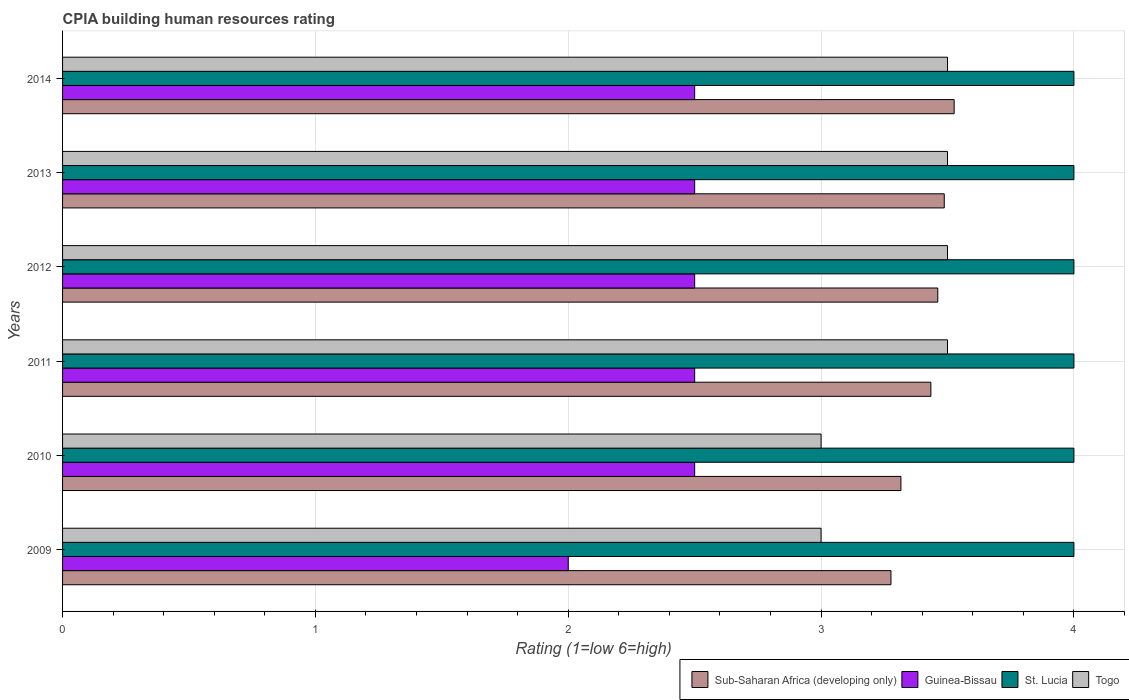Are the number of bars on each tick of the Y-axis equal?
Offer a very short reply. Yes. What is the label of the 5th group of bars from the top?
Keep it short and to the point. 2010. In how many cases, is the number of bars for a given year not equal to the number of legend labels?
Provide a succinct answer. 0. What is the CPIA rating in St. Lucia in 2010?
Your response must be concise. 4. Across all years, what is the maximum CPIA rating in St. Lucia?
Offer a very short reply. 4. Across all years, what is the minimum CPIA rating in Guinea-Bissau?
Keep it short and to the point. 2. In which year was the CPIA rating in Sub-Saharan Africa (developing only) maximum?
Your answer should be compact. 2014. What is the difference between the CPIA rating in Sub-Saharan Africa (developing only) in 2010 and that in 2013?
Offer a terse response. -0.17. What is the difference between the CPIA rating in Guinea-Bissau in 2011 and the CPIA rating in Togo in 2013?
Ensure brevity in your answer.  -1. What is the average CPIA rating in St. Lucia per year?
Offer a very short reply. 4. In how many years, is the CPIA rating in Togo greater than 0.2 ?
Give a very brief answer. 6. What is the ratio of the CPIA rating in Togo in 2010 to that in 2011?
Your response must be concise. 0.86. Is the CPIA rating in Sub-Saharan Africa (developing only) in 2009 less than that in 2013?
Provide a short and direct response. Yes. What is the difference between the highest and the second highest CPIA rating in Togo?
Make the answer very short. 0. Is it the case that in every year, the sum of the CPIA rating in St. Lucia and CPIA rating in Togo is greater than the sum of CPIA rating in Sub-Saharan Africa (developing only) and CPIA rating in Guinea-Bissau?
Offer a very short reply. No. What does the 1st bar from the top in 2009 represents?
Provide a succinct answer. Togo. What does the 3rd bar from the bottom in 2009 represents?
Make the answer very short. St. Lucia. Are all the bars in the graph horizontal?
Keep it short and to the point. Yes. What is the difference between two consecutive major ticks on the X-axis?
Your answer should be very brief. 1. Are the values on the major ticks of X-axis written in scientific E-notation?
Give a very brief answer. No. Where does the legend appear in the graph?
Provide a short and direct response. Bottom right. How many legend labels are there?
Give a very brief answer. 4. How are the legend labels stacked?
Keep it short and to the point. Horizontal. What is the title of the graph?
Offer a very short reply. CPIA building human resources rating. What is the label or title of the X-axis?
Make the answer very short. Rating (1=low 6=high). What is the Rating (1=low 6=high) of Sub-Saharan Africa (developing only) in 2009?
Your response must be concise. 3.28. What is the Rating (1=low 6=high) in Guinea-Bissau in 2009?
Provide a succinct answer. 2. What is the Rating (1=low 6=high) in St. Lucia in 2009?
Keep it short and to the point. 4. What is the Rating (1=low 6=high) of Togo in 2009?
Offer a terse response. 3. What is the Rating (1=low 6=high) in Sub-Saharan Africa (developing only) in 2010?
Make the answer very short. 3.32. What is the Rating (1=low 6=high) in Sub-Saharan Africa (developing only) in 2011?
Your answer should be very brief. 3.43. What is the Rating (1=low 6=high) in St. Lucia in 2011?
Your response must be concise. 4. What is the Rating (1=low 6=high) of Sub-Saharan Africa (developing only) in 2012?
Provide a short and direct response. 3.46. What is the Rating (1=low 6=high) of St. Lucia in 2012?
Ensure brevity in your answer.  4. What is the Rating (1=low 6=high) in Togo in 2012?
Offer a terse response. 3.5. What is the Rating (1=low 6=high) of Sub-Saharan Africa (developing only) in 2013?
Ensure brevity in your answer.  3.49. What is the Rating (1=low 6=high) in Sub-Saharan Africa (developing only) in 2014?
Your answer should be compact. 3.53. What is the Rating (1=low 6=high) of Guinea-Bissau in 2014?
Offer a very short reply. 2.5. What is the Rating (1=low 6=high) in St. Lucia in 2014?
Provide a short and direct response. 4. What is the Rating (1=low 6=high) in Togo in 2014?
Your response must be concise. 3.5. Across all years, what is the maximum Rating (1=low 6=high) of Sub-Saharan Africa (developing only)?
Your answer should be very brief. 3.53. Across all years, what is the maximum Rating (1=low 6=high) of Guinea-Bissau?
Offer a terse response. 2.5. Across all years, what is the maximum Rating (1=low 6=high) of St. Lucia?
Ensure brevity in your answer.  4. Across all years, what is the maximum Rating (1=low 6=high) of Togo?
Give a very brief answer. 3.5. Across all years, what is the minimum Rating (1=low 6=high) of Sub-Saharan Africa (developing only)?
Keep it short and to the point. 3.28. Across all years, what is the minimum Rating (1=low 6=high) in Guinea-Bissau?
Your response must be concise. 2. Across all years, what is the minimum Rating (1=low 6=high) of St. Lucia?
Your answer should be very brief. 4. Across all years, what is the minimum Rating (1=low 6=high) in Togo?
Give a very brief answer. 3. What is the total Rating (1=low 6=high) in Sub-Saharan Africa (developing only) in the graph?
Your response must be concise. 20.5. What is the total Rating (1=low 6=high) of Guinea-Bissau in the graph?
Ensure brevity in your answer.  14.5. What is the difference between the Rating (1=low 6=high) in Sub-Saharan Africa (developing only) in 2009 and that in 2010?
Provide a succinct answer. -0.04. What is the difference between the Rating (1=low 6=high) of Guinea-Bissau in 2009 and that in 2010?
Offer a terse response. -0.5. What is the difference between the Rating (1=low 6=high) in Sub-Saharan Africa (developing only) in 2009 and that in 2011?
Your response must be concise. -0.16. What is the difference between the Rating (1=low 6=high) in Guinea-Bissau in 2009 and that in 2011?
Your response must be concise. -0.5. What is the difference between the Rating (1=low 6=high) of St. Lucia in 2009 and that in 2011?
Provide a succinct answer. 0. What is the difference between the Rating (1=low 6=high) in Sub-Saharan Africa (developing only) in 2009 and that in 2012?
Provide a short and direct response. -0.19. What is the difference between the Rating (1=low 6=high) in St. Lucia in 2009 and that in 2012?
Offer a very short reply. 0. What is the difference between the Rating (1=low 6=high) of Sub-Saharan Africa (developing only) in 2009 and that in 2013?
Offer a very short reply. -0.21. What is the difference between the Rating (1=low 6=high) of Togo in 2009 and that in 2013?
Your response must be concise. -0.5. What is the difference between the Rating (1=low 6=high) in Guinea-Bissau in 2009 and that in 2014?
Your answer should be very brief. -0.5. What is the difference between the Rating (1=low 6=high) of Sub-Saharan Africa (developing only) in 2010 and that in 2011?
Ensure brevity in your answer.  -0.12. What is the difference between the Rating (1=low 6=high) of Guinea-Bissau in 2010 and that in 2011?
Offer a very short reply. 0. What is the difference between the Rating (1=low 6=high) of Sub-Saharan Africa (developing only) in 2010 and that in 2012?
Keep it short and to the point. -0.15. What is the difference between the Rating (1=low 6=high) of St. Lucia in 2010 and that in 2012?
Ensure brevity in your answer.  0. What is the difference between the Rating (1=low 6=high) in Togo in 2010 and that in 2012?
Make the answer very short. -0.5. What is the difference between the Rating (1=low 6=high) of Sub-Saharan Africa (developing only) in 2010 and that in 2013?
Your answer should be very brief. -0.17. What is the difference between the Rating (1=low 6=high) of Guinea-Bissau in 2010 and that in 2013?
Your answer should be compact. 0. What is the difference between the Rating (1=low 6=high) of Togo in 2010 and that in 2013?
Keep it short and to the point. -0.5. What is the difference between the Rating (1=low 6=high) of Sub-Saharan Africa (developing only) in 2010 and that in 2014?
Ensure brevity in your answer.  -0.21. What is the difference between the Rating (1=low 6=high) of Guinea-Bissau in 2010 and that in 2014?
Ensure brevity in your answer.  0. What is the difference between the Rating (1=low 6=high) in St. Lucia in 2010 and that in 2014?
Ensure brevity in your answer.  0. What is the difference between the Rating (1=low 6=high) in Sub-Saharan Africa (developing only) in 2011 and that in 2012?
Your answer should be very brief. -0.03. What is the difference between the Rating (1=low 6=high) in Togo in 2011 and that in 2012?
Offer a terse response. 0. What is the difference between the Rating (1=low 6=high) of Sub-Saharan Africa (developing only) in 2011 and that in 2013?
Your answer should be compact. -0.05. What is the difference between the Rating (1=low 6=high) of St. Lucia in 2011 and that in 2013?
Make the answer very short. 0. What is the difference between the Rating (1=low 6=high) of Togo in 2011 and that in 2013?
Your answer should be very brief. 0. What is the difference between the Rating (1=low 6=high) of Sub-Saharan Africa (developing only) in 2011 and that in 2014?
Provide a short and direct response. -0.09. What is the difference between the Rating (1=low 6=high) in St. Lucia in 2011 and that in 2014?
Make the answer very short. 0. What is the difference between the Rating (1=low 6=high) of Sub-Saharan Africa (developing only) in 2012 and that in 2013?
Keep it short and to the point. -0.03. What is the difference between the Rating (1=low 6=high) of Guinea-Bissau in 2012 and that in 2013?
Provide a short and direct response. 0. What is the difference between the Rating (1=low 6=high) of St. Lucia in 2012 and that in 2013?
Your answer should be very brief. 0. What is the difference between the Rating (1=low 6=high) in Sub-Saharan Africa (developing only) in 2012 and that in 2014?
Offer a terse response. -0.06. What is the difference between the Rating (1=low 6=high) in Guinea-Bissau in 2012 and that in 2014?
Make the answer very short. 0. What is the difference between the Rating (1=low 6=high) of Togo in 2012 and that in 2014?
Provide a succinct answer. 0. What is the difference between the Rating (1=low 6=high) of Sub-Saharan Africa (developing only) in 2013 and that in 2014?
Give a very brief answer. -0.04. What is the difference between the Rating (1=low 6=high) of Sub-Saharan Africa (developing only) in 2009 and the Rating (1=low 6=high) of Guinea-Bissau in 2010?
Offer a very short reply. 0.78. What is the difference between the Rating (1=low 6=high) of Sub-Saharan Africa (developing only) in 2009 and the Rating (1=low 6=high) of St. Lucia in 2010?
Keep it short and to the point. -0.72. What is the difference between the Rating (1=low 6=high) in Sub-Saharan Africa (developing only) in 2009 and the Rating (1=low 6=high) in Togo in 2010?
Offer a very short reply. 0.28. What is the difference between the Rating (1=low 6=high) of Sub-Saharan Africa (developing only) in 2009 and the Rating (1=low 6=high) of Guinea-Bissau in 2011?
Your answer should be compact. 0.78. What is the difference between the Rating (1=low 6=high) of Sub-Saharan Africa (developing only) in 2009 and the Rating (1=low 6=high) of St. Lucia in 2011?
Your answer should be compact. -0.72. What is the difference between the Rating (1=low 6=high) of Sub-Saharan Africa (developing only) in 2009 and the Rating (1=low 6=high) of Togo in 2011?
Keep it short and to the point. -0.22. What is the difference between the Rating (1=low 6=high) of St. Lucia in 2009 and the Rating (1=low 6=high) of Togo in 2011?
Give a very brief answer. 0.5. What is the difference between the Rating (1=low 6=high) in Sub-Saharan Africa (developing only) in 2009 and the Rating (1=low 6=high) in Guinea-Bissau in 2012?
Offer a very short reply. 0.78. What is the difference between the Rating (1=low 6=high) in Sub-Saharan Africa (developing only) in 2009 and the Rating (1=low 6=high) in St. Lucia in 2012?
Your answer should be compact. -0.72. What is the difference between the Rating (1=low 6=high) of Sub-Saharan Africa (developing only) in 2009 and the Rating (1=low 6=high) of Togo in 2012?
Give a very brief answer. -0.22. What is the difference between the Rating (1=low 6=high) in Guinea-Bissau in 2009 and the Rating (1=low 6=high) in St. Lucia in 2012?
Provide a succinct answer. -2. What is the difference between the Rating (1=low 6=high) of St. Lucia in 2009 and the Rating (1=low 6=high) of Togo in 2012?
Provide a short and direct response. 0.5. What is the difference between the Rating (1=low 6=high) of Sub-Saharan Africa (developing only) in 2009 and the Rating (1=low 6=high) of Guinea-Bissau in 2013?
Your answer should be very brief. 0.78. What is the difference between the Rating (1=low 6=high) in Sub-Saharan Africa (developing only) in 2009 and the Rating (1=low 6=high) in St. Lucia in 2013?
Offer a very short reply. -0.72. What is the difference between the Rating (1=low 6=high) in Sub-Saharan Africa (developing only) in 2009 and the Rating (1=low 6=high) in Togo in 2013?
Offer a very short reply. -0.22. What is the difference between the Rating (1=low 6=high) in Guinea-Bissau in 2009 and the Rating (1=low 6=high) in Togo in 2013?
Provide a short and direct response. -1.5. What is the difference between the Rating (1=low 6=high) of St. Lucia in 2009 and the Rating (1=low 6=high) of Togo in 2013?
Provide a short and direct response. 0.5. What is the difference between the Rating (1=low 6=high) in Sub-Saharan Africa (developing only) in 2009 and the Rating (1=low 6=high) in Guinea-Bissau in 2014?
Your answer should be compact. 0.78. What is the difference between the Rating (1=low 6=high) of Sub-Saharan Africa (developing only) in 2009 and the Rating (1=low 6=high) of St. Lucia in 2014?
Give a very brief answer. -0.72. What is the difference between the Rating (1=low 6=high) of Sub-Saharan Africa (developing only) in 2009 and the Rating (1=low 6=high) of Togo in 2014?
Your response must be concise. -0.22. What is the difference between the Rating (1=low 6=high) of Guinea-Bissau in 2009 and the Rating (1=low 6=high) of St. Lucia in 2014?
Make the answer very short. -2. What is the difference between the Rating (1=low 6=high) in Sub-Saharan Africa (developing only) in 2010 and the Rating (1=low 6=high) in Guinea-Bissau in 2011?
Your response must be concise. 0.82. What is the difference between the Rating (1=low 6=high) in Sub-Saharan Africa (developing only) in 2010 and the Rating (1=low 6=high) in St. Lucia in 2011?
Provide a succinct answer. -0.68. What is the difference between the Rating (1=low 6=high) of Sub-Saharan Africa (developing only) in 2010 and the Rating (1=low 6=high) of Togo in 2011?
Offer a terse response. -0.18. What is the difference between the Rating (1=low 6=high) in Guinea-Bissau in 2010 and the Rating (1=low 6=high) in St. Lucia in 2011?
Keep it short and to the point. -1.5. What is the difference between the Rating (1=low 6=high) of Guinea-Bissau in 2010 and the Rating (1=low 6=high) of Togo in 2011?
Provide a succinct answer. -1. What is the difference between the Rating (1=low 6=high) in St. Lucia in 2010 and the Rating (1=low 6=high) in Togo in 2011?
Keep it short and to the point. 0.5. What is the difference between the Rating (1=low 6=high) in Sub-Saharan Africa (developing only) in 2010 and the Rating (1=low 6=high) in Guinea-Bissau in 2012?
Offer a terse response. 0.82. What is the difference between the Rating (1=low 6=high) in Sub-Saharan Africa (developing only) in 2010 and the Rating (1=low 6=high) in St. Lucia in 2012?
Keep it short and to the point. -0.68. What is the difference between the Rating (1=low 6=high) in Sub-Saharan Africa (developing only) in 2010 and the Rating (1=low 6=high) in Togo in 2012?
Your answer should be compact. -0.18. What is the difference between the Rating (1=low 6=high) in Guinea-Bissau in 2010 and the Rating (1=low 6=high) in St. Lucia in 2012?
Provide a succinct answer. -1.5. What is the difference between the Rating (1=low 6=high) of Sub-Saharan Africa (developing only) in 2010 and the Rating (1=low 6=high) of Guinea-Bissau in 2013?
Offer a very short reply. 0.82. What is the difference between the Rating (1=low 6=high) of Sub-Saharan Africa (developing only) in 2010 and the Rating (1=low 6=high) of St. Lucia in 2013?
Your answer should be very brief. -0.68. What is the difference between the Rating (1=low 6=high) of Sub-Saharan Africa (developing only) in 2010 and the Rating (1=low 6=high) of Togo in 2013?
Your answer should be compact. -0.18. What is the difference between the Rating (1=low 6=high) of Sub-Saharan Africa (developing only) in 2010 and the Rating (1=low 6=high) of Guinea-Bissau in 2014?
Your response must be concise. 0.82. What is the difference between the Rating (1=low 6=high) in Sub-Saharan Africa (developing only) in 2010 and the Rating (1=low 6=high) in St. Lucia in 2014?
Provide a short and direct response. -0.68. What is the difference between the Rating (1=low 6=high) of Sub-Saharan Africa (developing only) in 2010 and the Rating (1=low 6=high) of Togo in 2014?
Provide a short and direct response. -0.18. What is the difference between the Rating (1=low 6=high) of Guinea-Bissau in 2010 and the Rating (1=low 6=high) of St. Lucia in 2014?
Give a very brief answer. -1.5. What is the difference between the Rating (1=low 6=high) of Guinea-Bissau in 2010 and the Rating (1=low 6=high) of Togo in 2014?
Your response must be concise. -1. What is the difference between the Rating (1=low 6=high) in St. Lucia in 2010 and the Rating (1=low 6=high) in Togo in 2014?
Offer a terse response. 0.5. What is the difference between the Rating (1=low 6=high) in Sub-Saharan Africa (developing only) in 2011 and the Rating (1=low 6=high) in Guinea-Bissau in 2012?
Provide a succinct answer. 0.93. What is the difference between the Rating (1=low 6=high) of Sub-Saharan Africa (developing only) in 2011 and the Rating (1=low 6=high) of St. Lucia in 2012?
Provide a short and direct response. -0.57. What is the difference between the Rating (1=low 6=high) in Sub-Saharan Africa (developing only) in 2011 and the Rating (1=low 6=high) in Togo in 2012?
Ensure brevity in your answer.  -0.07. What is the difference between the Rating (1=low 6=high) of Guinea-Bissau in 2011 and the Rating (1=low 6=high) of St. Lucia in 2012?
Offer a very short reply. -1.5. What is the difference between the Rating (1=low 6=high) of St. Lucia in 2011 and the Rating (1=low 6=high) of Togo in 2012?
Offer a terse response. 0.5. What is the difference between the Rating (1=low 6=high) in Sub-Saharan Africa (developing only) in 2011 and the Rating (1=low 6=high) in Guinea-Bissau in 2013?
Offer a terse response. 0.93. What is the difference between the Rating (1=low 6=high) in Sub-Saharan Africa (developing only) in 2011 and the Rating (1=low 6=high) in St. Lucia in 2013?
Offer a terse response. -0.57. What is the difference between the Rating (1=low 6=high) of Sub-Saharan Africa (developing only) in 2011 and the Rating (1=low 6=high) of Togo in 2013?
Offer a terse response. -0.07. What is the difference between the Rating (1=low 6=high) in Guinea-Bissau in 2011 and the Rating (1=low 6=high) in St. Lucia in 2013?
Keep it short and to the point. -1.5. What is the difference between the Rating (1=low 6=high) in Guinea-Bissau in 2011 and the Rating (1=low 6=high) in Togo in 2013?
Provide a short and direct response. -1. What is the difference between the Rating (1=low 6=high) in St. Lucia in 2011 and the Rating (1=low 6=high) in Togo in 2013?
Your answer should be compact. 0.5. What is the difference between the Rating (1=low 6=high) of Sub-Saharan Africa (developing only) in 2011 and the Rating (1=low 6=high) of Guinea-Bissau in 2014?
Provide a short and direct response. 0.93. What is the difference between the Rating (1=low 6=high) of Sub-Saharan Africa (developing only) in 2011 and the Rating (1=low 6=high) of St. Lucia in 2014?
Ensure brevity in your answer.  -0.57. What is the difference between the Rating (1=low 6=high) in Sub-Saharan Africa (developing only) in 2011 and the Rating (1=low 6=high) in Togo in 2014?
Offer a very short reply. -0.07. What is the difference between the Rating (1=low 6=high) in Guinea-Bissau in 2011 and the Rating (1=low 6=high) in St. Lucia in 2014?
Keep it short and to the point. -1.5. What is the difference between the Rating (1=low 6=high) in Guinea-Bissau in 2011 and the Rating (1=low 6=high) in Togo in 2014?
Your answer should be compact. -1. What is the difference between the Rating (1=low 6=high) in Sub-Saharan Africa (developing only) in 2012 and the Rating (1=low 6=high) in Guinea-Bissau in 2013?
Ensure brevity in your answer.  0.96. What is the difference between the Rating (1=low 6=high) of Sub-Saharan Africa (developing only) in 2012 and the Rating (1=low 6=high) of St. Lucia in 2013?
Your response must be concise. -0.54. What is the difference between the Rating (1=low 6=high) of Sub-Saharan Africa (developing only) in 2012 and the Rating (1=low 6=high) of Togo in 2013?
Your answer should be very brief. -0.04. What is the difference between the Rating (1=low 6=high) in Guinea-Bissau in 2012 and the Rating (1=low 6=high) in Togo in 2013?
Provide a short and direct response. -1. What is the difference between the Rating (1=low 6=high) of St. Lucia in 2012 and the Rating (1=low 6=high) of Togo in 2013?
Offer a very short reply. 0.5. What is the difference between the Rating (1=low 6=high) of Sub-Saharan Africa (developing only) in 2012 and the Rating (1=low 6=high) of Guinea-Bissau in 2014?
Give a very brief answer. 0.96. What is the difference between the Rating (1=low 6=high) of Sub-Saharan Africa (developing only) in 2012 and the Rating (1=low 6=high) of St. Lucia in 2014?
Provide a succinct answer. -0.54. What is the difference between the Rating (1=low 6=high) of Sub-Saharan Africa (developing only) in 2012 and the Rating (1=low 6=high) of Togo in 2014?
Your response must be concise. -0.04. What is the difference between the Rating (1=low 6=high) in Guinea-Bissau in 2012 and the Rating (1=low 6=high) in St. Lucia in 2014?
Offer a very short reply. -1.5. What is the difference between the Rating (1=low 6=high) of Guinea-Bissau in 2012 and the Rating (1=low 6=high) of Togo in 2014?
Give a very brief answer. -1. What is the difference between the Rating (1=low 6=high) of St. Lucia in 2012 and the Rating (1=low 6=high) of Togo in 2014?
Give a very brief answer. 0.5. What is the difference between the Rating (1=low 6=high) in Sub-Saharan Africa (developing only) in 2013 and the Rating (1=low 6=high) in Guinea-Bissau in 2014?
Keep it short and to the point. 0.99. What is the difference between the Rating (1=low 6=high) in Sub-Saharan Africa (developing only) in 2013 and the Rating (1=low 6=high) in St. Lucia in 2014?
Give a very brief answer. -0.51. What is the difference between the Rating (1=low 6=high) in Sub-Saharan Africa (developing only) in 2013 and the Rating (1=low 6=high) in Togo in 2014?
Ensure brevity in your answer.  -0.01. What is the average Rating (1=low 6=high) in Sub-Saharan Africa (developing only) per year?
Offer a very short reply. 3.42. What is the average Rating (1=low 6=high) of Guinea-Bissau per year?
Make the answer very short. 2.42. What is the average Rating (1=low 6=high) of St. Lucia per year?
Your answer should be compact. 4. In the year 2009, what is the difference between the Rating (1=low 6=high) in Sub-Saharan Africa (developing only) and Rating (1=low 6=high) in Guinea-Bissau?
Your answer should be compact. 1.28. In the year 2009, what is the difference between the Rating (1=low 6=high) of Sub-Saharan Africa (developing only) and Rating (1=low 6=high) of St. Lucia?
Your answer should be very brief. -0.72. In the year 2009, what is the difference between the Rating (1=low 6=high) in Sub-Saharan Africa (developing only) and Rating (1=low 6=high) in Togo?
Your answer should be very brief. 0.28. In the year 2009, what is the difference between the Rating (1=low 6=high) in Guinea-Bissau and Rating (1=low 6=high) in Togo?
Ensure brevity in your answer.  -1. In the year 2010, what is the difference between the Rating (1=low 6=high) in Sub-Saharan Africa (developing only) and Rating (1=low 6=high) in Guinea-Bissau?
Keep it short and to the point. 0.82. In the year 2010, what is the difference between the Rating (1=low 6=high) of Sub-Saharan Africa (developing only) and Rating (1=low 6=high) of St. Lucia?
Provide a short and direct response. -0.68. In the year 2010, what is the difference between the Rating (1=low 6=high) in Sub-Saharan Africa (developing only) and Rating (1=low 6=high) in Togo?
Offer a terse response. 0.32. In the year 2010, what is the difference between the Rating (1=low 6=high) of Guinea-Bissau and Rating (1=low 6=high) of St. Lucia?
Your response must be concise. -1.5. In the year 2010, what is the difference between the Rating (1=low 6=high) of Guinea-Bissau and Rating (1=low 6=high) of Togo?
Offer a terse response. -0.5. In the year 2011, what is the difference between the Rating (1=low 6=high) in Sub-Saharan Africa (developing only) and Rating (1=low 6=high) in Guinea-Bissau?
Offer a terse response. 0.93. In the year 2011, what is the difference between the Rating (1=low 6=high) in Sub-Saharan Africa (developing only) and Rating (1=low 6=high) in St. Lucia?
Provide a short and direct response. -0.57. In the year 2011, what is the difference between the Rating (1=low 6=high) of Sub-Saharan Africa (developing only) and Rating (1=low 6=high) of Togo?
Your answer should be compact. -0.07. In the year 2011, what is the difference between the Rating (1=low 6=high) of Guinea-Bissau and Rating (1=low 6=high) of St. Lucia?
Offer a terse response. -1.5. In the year 2011, what is the difference between the Rating (1=low 6=high) of Guinea-Bissau and Rating (1=low 6=high) of Togo?
Your response must be concise. -1. In the year 2012, what is the difference between the Rating (1=low 6=high) in Sub-Saharan Africa (developing only) and Rating (1=low 6=high) in Guinea-Bissau?
Give a very brief answer. 0.96. In the year 2012, what is the difference between the Rating (1=low 6=high) of Sub-Saharan Africa (developing only) and Rating (1=low 6=high) of St. Lucia?
Provide a succinct answer. -0.54. In the year 2012, what is the difference between the Rating (1=low 6=high) of Sub-Saharan Africa (developing only) and Rating (1=low 6=high) of Togo?
Give a very brief answer. -0.04. In the year 2013, what is the difference between the Rating (1=low 6=high) of Sub-Saharan Africa (developing only) and Rating (1=low 6=high) of Guinea-Bissau?
Your answer should be compact. 0.99. In the year 2013, what is the difference between the Rating (1=low 6=high) of Sub-Saharan Africa (developing only) and Rating (1=low 6=high) of St. Lucia?
Your answer should be very brief. -0.51. In the year 2013, what is the difference between the Rating (1=low 6=high) in Sub-Saharan Africa (developing only) and Rating (1=low 6=high) in Togo?
Ensure brevity in your answer.  -0.01. In the year 2013, what is the difference between the Rating (1=low 6=high) of Guinea-Bissau and Rating (1=low 6=high) of Togo?
Ensure brevity in your answer.  -1. In the year 2013, what is the difference between the Rating (1=low 6=high) of St. Lucia and Rating (1=low 6=high) of Togo?
Your response must be concise. 0.5. In the year 2014, what is the difference between the Rating (1=low 6=high) of Sub-Saharan Africa (developing only) and Rating (1=low 6=high) of Guinea-Bissau?
Provide a short and direct response. 1.03. In the year 2014, what is the difference between the Rating (1=low 6=high) in Sub-Saharan Africa (developing only) and Rating (1=low 6=high) in St. Lucia?
Give a very brief answer. -0.47. In the year 2014, what is the difference between the Rating (1=low 6=high) in Sub-Saharan Africa (developing only) and Rating (1=low 6=high) in Togo?
Give a very brief answer. 0.03. In the year 2014, what is the difference between the Rating (1=low 6=high) in Guinea-Bissau and Rating (1=low 6=high) in St. Lucia?
Give a very brief answer. -1.5. What is the ratio of the Rating (1=low 6=high) of Guinea-Bissau in 2009 to that in 2010?
Provide a short and direct response. 0.8. What is the ratio of the Rating (1=low 6=high) of Sub-Saharan Africa (developing only) in 2009 to that in 2011?
Keep it short and to the point. 0.95. What is the ratio of the Rating (1=low 6=high) of Guinea-Bissau in 2009 to that in 2011?
Provide a succinct answer. 0.8. What is the ratio of the Rating (1=low 6=high) in St. Lucia in 2009 to that in 2011?
Your answer should be very brief. 1. What is the ratio of the Rating (1=low 6=high) in Sub-Saharan Africa (developing only) in 2009 to that in 2012?
Your response must be concise. 0.95. What is the ratio of the Rating (1=low 6=high) in Guinea-Bissau in 2009 to that in 2012?
Make the answer very short. 0.8. What is the ratio of the Rating (1=low 6=high) of Togo in 2009 to that in 2012?
Give a very brief answer. 0.86. What is the ratio of the Rating (1=low 6=high) of Sub-Saharan Africa (developing only) in 2009 to that in 2013?
Your response must be concise. 0.94. What is the ratio of the Rating (1=low 6=high) in St. Lucia in 2009 to that in 2013?
Your answer should be compact. 1. What is the ratio of the Rating (1=low 6=high) of Togo in 2009 to that in 2013?
Provide a succinct answer. 0.86. What is the ratio of the Rating (1=low 6=high) of Sub-Saharan Africa (developing only) in 2009 to that in 2014?
Your answer should be very brief. 0.93. What is the ratio of the Rating (1=low 6=high) in St. Lucia in 2009 to that in 2014?
Give a very brief answer. 1. What is the ratio of the Rating (1=low 6=high) of Sub-Saharan Africa (developing only) in 2010 to that in 2011?
Ensure brevity in your answer.  0.97. What is the ratio of the Rating (1=low 6=high) in St. Lucia in 2010 to that in 2011?
Your response must be concise. 1. What is the ratio of the Rating (1=low 6=high) of Sub-Saharan Africa (developing only) in 2010 to that in 2012?
Your response must be concise. 0.96. What is the ratio of the Rating (1=low 6=high) of St. Lucia in 2010 to that in 2012?
Make the answer very short. 1. What is the ratio of the Rating (1=low 6=high) of Togo in 2010 to that in 2012?
Keep it short and to the point. 0.86. What is the ratio of the Rating (1=low 6=high) of Sub-Saharan Africa (developing only) in 2010 to that in 2013?
Your response must be concise. 0.95. What is the ratio of the Rating (1=low 6=high) in Guinea-Bissau in 2010 to that in 2013?
Provide a succinct answer. 1. What is the ratio of the Rating (1=low 6=high) in Togo in 2010 to that in 2013?
Your answer should be compact. 0.86. What is the ratio of the Rating (1=low 6=high) in Sub-Saharan Africa (developing only) in 2010 to that in 2014?
Your response must be concise. 0.94. What is the ratio of the Rating (1=low 6=high) of St. Lucia in 2010 to that in 2014?
Your response must be concise. 1. What is the ratio of the Rating (1=low 6=high) of Guinea-Bissau in 2011 to that in 2012?
Your answer should be very brief. 1. What is the ratio of the Rating (1=low 6=high) in Togo in 2011 to that in 2012?
Give a very brief answer. 1. What is the ratio of the Rating (1=low 6=high) in Guinea-Bissau in 2011 to that in 2013?
Ensure brevity in your answer.  1. What is the ratio of the Rating (1=low 6=high) in Sub-Saharan Africa (developing only) in 2011 to that in 2014?
Make the answer very short. 0.97. What is the ratio of the Rating (1=low 6=high) in Guinea-Bissau in 2011 to that in 2014?
Make the answer very short. 1. What is the ratio of the Rating (1=low 6=high) of Sub-Saharan Africa (developing only) in 2012 to that in 2013?
Offer a terse response. 0.99. What is the ratio of the Rating (1=low 6=high) of Togo in 2012 to that in 2013?
Offer a very short reply. 1. What is the ratio of the Rating (1=low 6=high) of Sub-Saharan Africa (developing only) in 2012 to that in 2014?
Provide a short and direct response. 0.98. What is the ratio of the Rating (1=low 6=high) of Sub-Saharan Africa (developing only) in 2013 to that in 2014?
Keep it short and to the point. 0.99. What is the ratio of the Rating (1=low 6=high) of Guinea-Bissau in 2013 to that in 2014?
Your response must be concise. 1. What is the difference between the highest and the second highest Rating (1=low 6=high) in Sub-Saharan Africa (developing only)?
Ensure brevity in your answer.  0.04. What is the difference between the highest and the second highest Rating (1=low 6=high) in Guinea-Bissau?
Your response must be concise. 0. What is the difference between the highest and the second highest Rating (1=low 6=high) of St. Lucia?
Make the answer very short. 0. What is the difference between the highest and the second highest Rating (1=low 6=high) in Togo?
Your answer should be very brief. 0. What is the difference between the highest and the lowest Rating (1=low 6=high) of St. Lucia?
Keep it short and to the point. 0. 